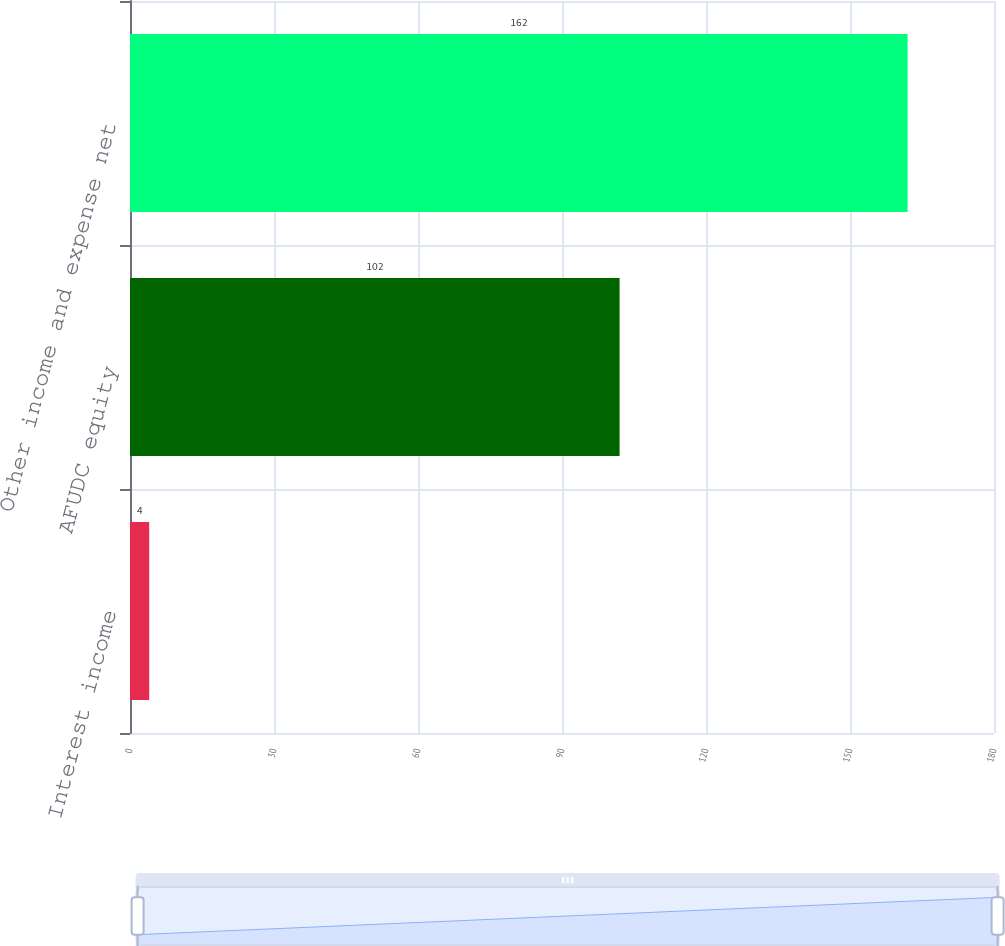Convert chart. <chart><loc_0><loc_0><loc_500><loc_500><bar_chart><fcel>Interest income<fcel>AFUDC equity<fcel>Other income and expense net<nl><fcel>4<fcel>102<fcel>162<nl></chart> 